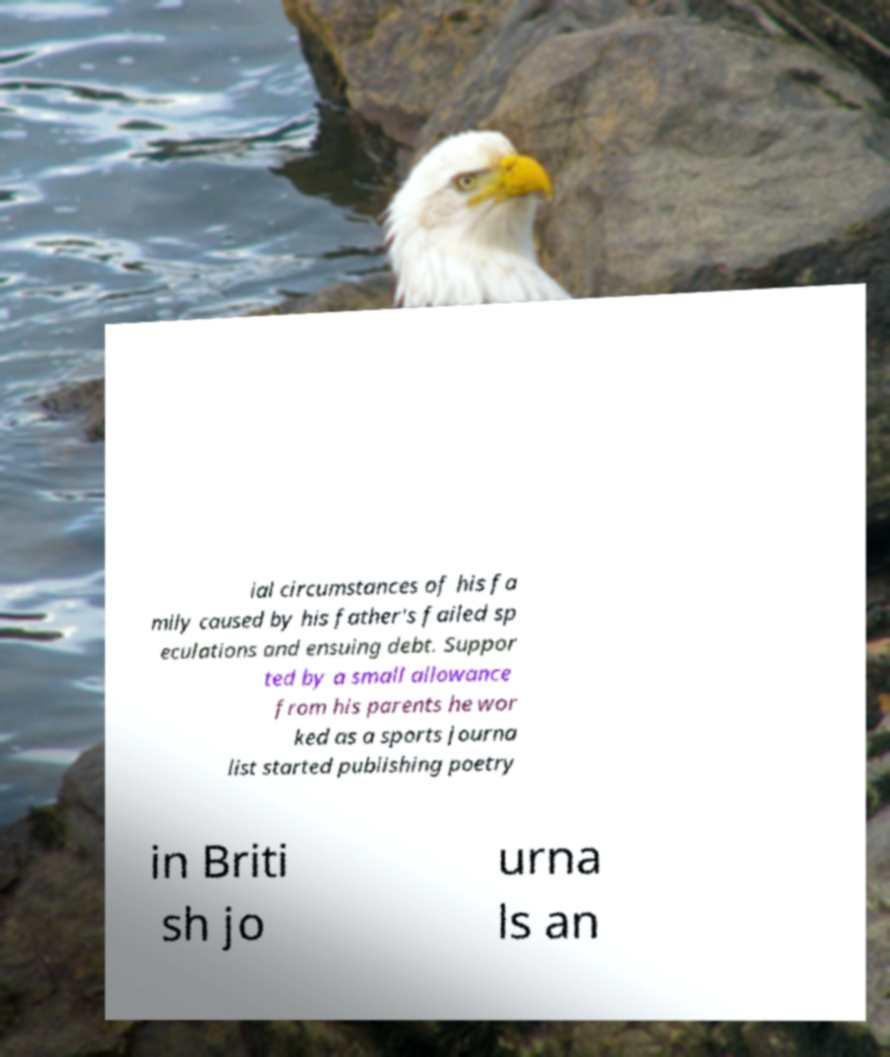Can you accurately transcribe the text from the provided image for me? ial circumstances of his fa mily caused by his father's failed sp eculations and ensuing debt. Suppor ted by a small allowance from his parents he wor ked as a sports journa list started publishing poetry in Briti sh jo urna ls an 